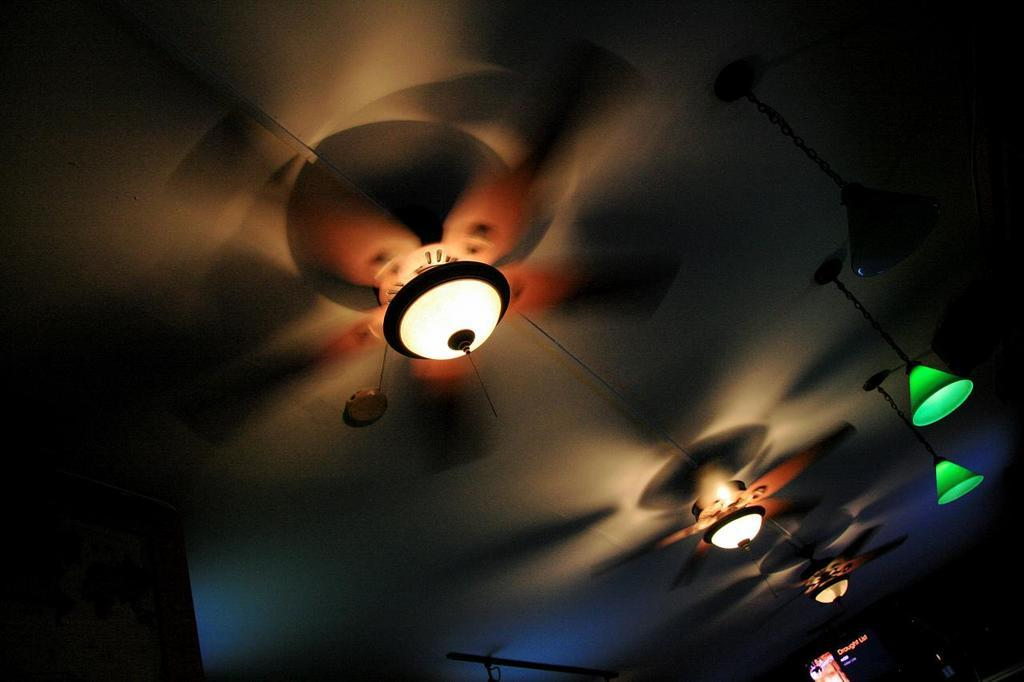What objects are located at the top of the image? There are fans at the top of the image. What is positioned between the fans? There is a light in between the fans. Are there any other lights visible in the image? Yes, there are lights hanging from the roof beside the fans. How many sticks are being used to hold up the fans in the image? There is no mention of sticks being used to hold up the fans in the image. The fans appear to be attached to the ceiling or wall. 